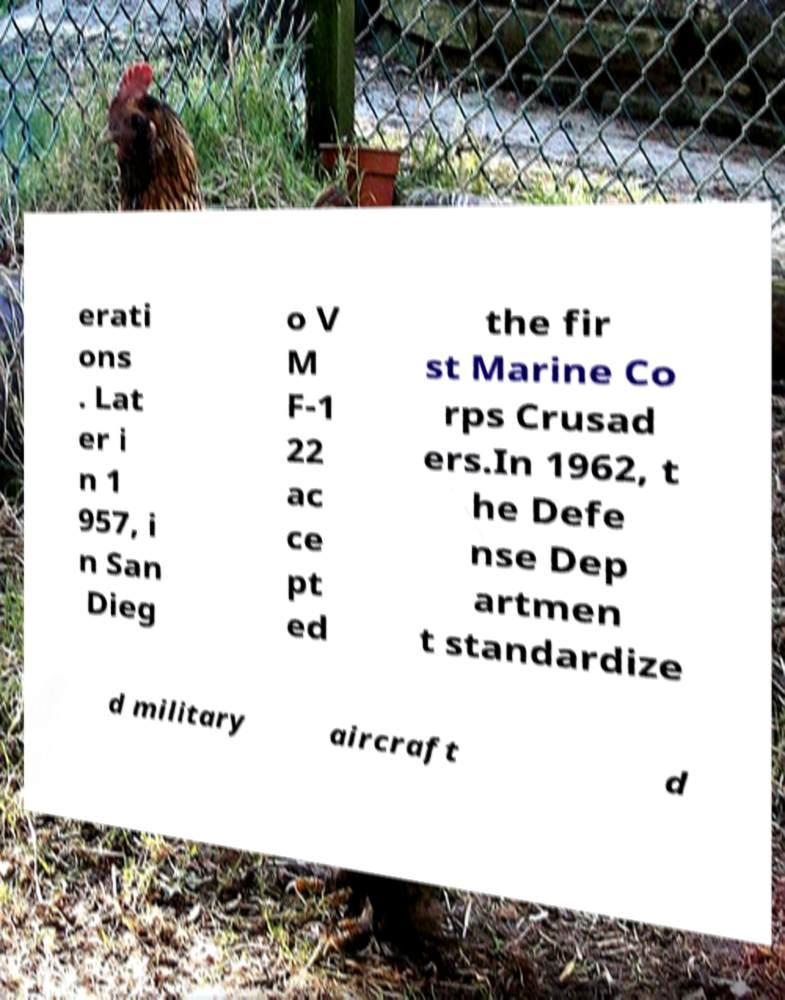There's text embedded in this image that I need extracted. Can you transcribe it verbatim? erati ons . Lat er i n 1 957, i n San Dieg o V M F-1 22 ac ce pt ed the fir st Marine Co rps Crusad ers.In 1962, t he Defe nse Dep artmen t standardize d military aircraft d 